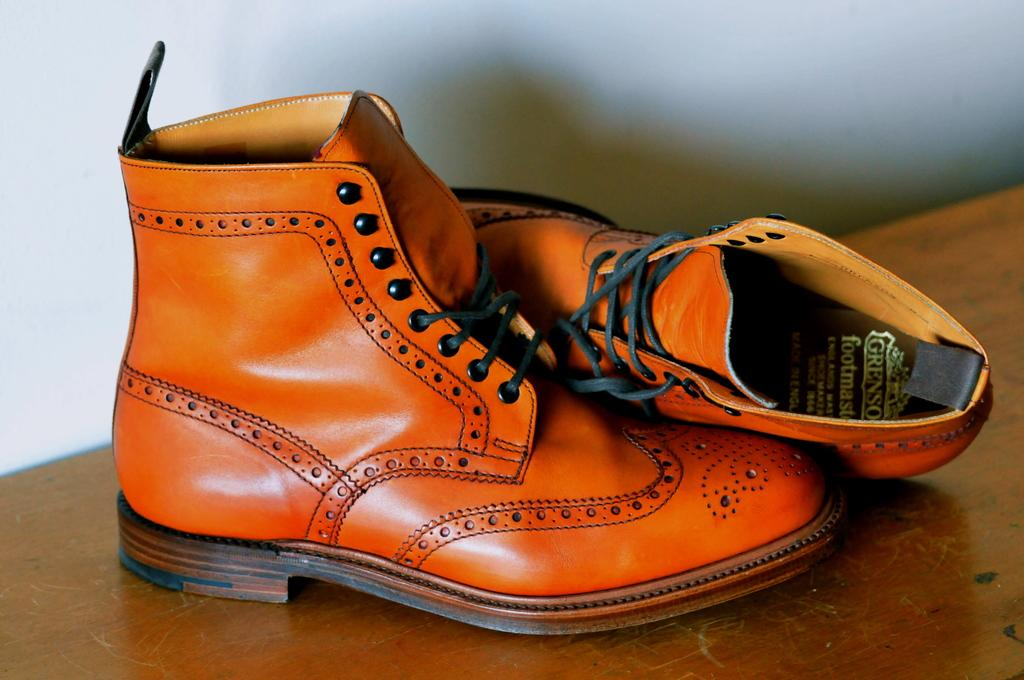What type of footwear is visible in the image? There is a pair of brown color shoes in the image. Where are the shoes located? The shoes are on a table. What type of farm animal is wearing the brown shoes in the image? There are no farm animals or any indication of an animal wearing shoes in the image. What type of scarf is draped over the shoes in the image? There is no scarf present in the image; it only features a pair of brown color shoes on a table. 